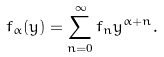<formula> <loc_0><loc_0><loc_500><loc_500>f _ { \alpha } ( y ) = \sum _ { n = 0 } ^ { \infty } f _ { n } y ^ { \alpha + n } .</formula> 